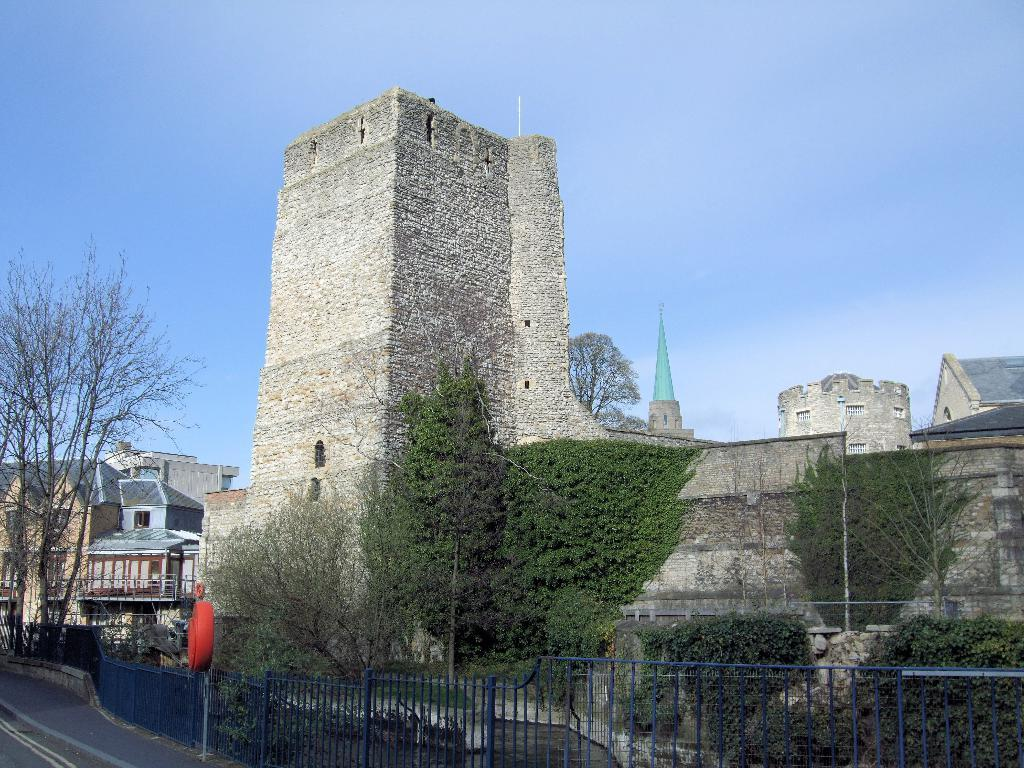What type of structures can be seen in the image? There are buildings in the image. What other natural elements are present in the image? There are trees in the image. What type of barrier can be seen in the image? There is a metal fence in the image. What is attached to a pole on the sidewalk in the image? There is a board attached to a pole on the sidewalk. What is the color of the sky in the image? The sky is blue in the image. Can you tell me how many basketballs are visible in the image? There are no basketballs present in the image. What type of shade is provided by the trees in the image? The trees in the image do not provide shade, as the presence of the sun is not mentioned. 